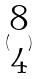<formula> <loc_0><loc_0><loc_500><loc_500>( \begin{matrix} 8 \\ 4 \end{matrix} )</formula> 